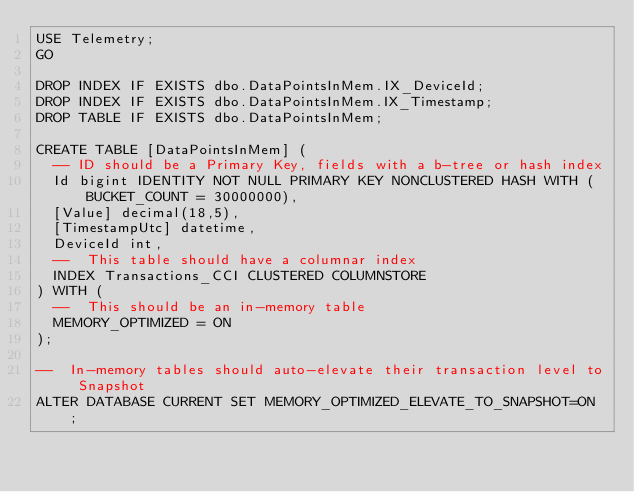<code> <loc_0><loc_0><loc_500><loc_500><_SQL_>USE Telemetry;
GO

DROP INDEX IF EXISTS dbo.DataPointsInMem.IX_DeviceId;
DROP INDEX IF EXISTS dbo.DataPointsInMem.IX_Timestamp;
DROP TABLE IF EXISTS dbo.DataPointsInMem;

CREATE TABLE [DataPointsInMem] (
	-- ID should be a Primary Key, fields with a b-tree or hash index
	Id bigint IDENTITY NOT NULL PRIMARY KEY NONCLUSTERED HASH WITH (BUCKET_COUNT = 30000000),
	[Value] decimal(18,5),
	[TimestampUtc] datetime,
	DeviceId int,
	--  This table should have a columnar index
	INDEX Transactions_CCI CLUSTERED COLUMNSTORE
) WITH (
	--  This should be an in-memory table
	MEMORY_OPTIMIZED = ON
);

--  In-memory tables should auto-elevate their transaction level to Snapshot
ALTER DATABASE CURRENT SET MEMORY_OPTIMIZED_ELEVATE_TO_SNAPSHOT=ON ; 
</code> 